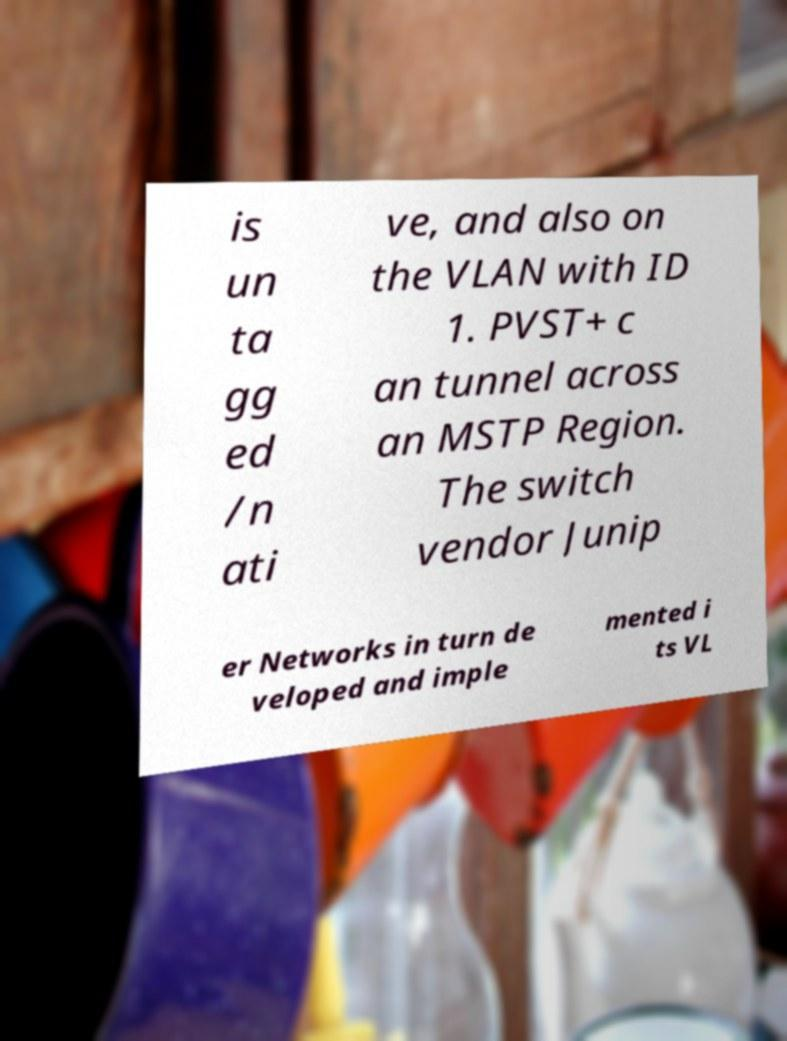There's text embedded in this image that I need extracted. Can you transcribe it verbatim? is un ta gg ed /n ati ve, and also on the VLAN with ID 1. PVST+ c an tunnel across an MSTP Region. The switch vendor Junip er Networks in turn de veloped and imple mented i ts VL 